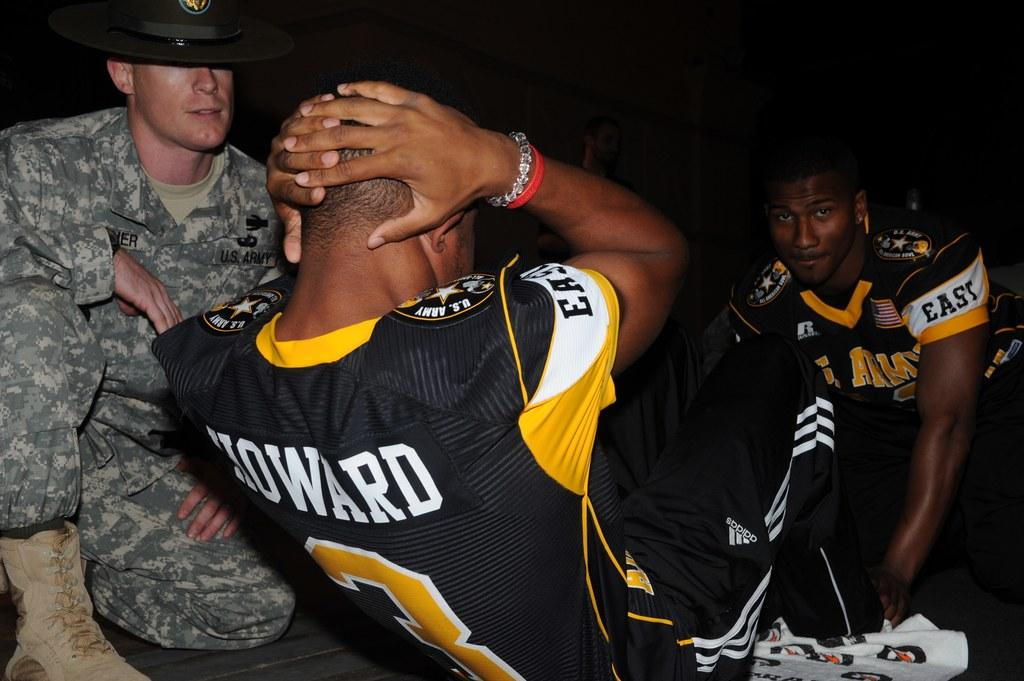<image>
Present a compact description of the photo's key features. Two guys wearing sports tops, one with Howard on the back are approached by a man in camo gear. 